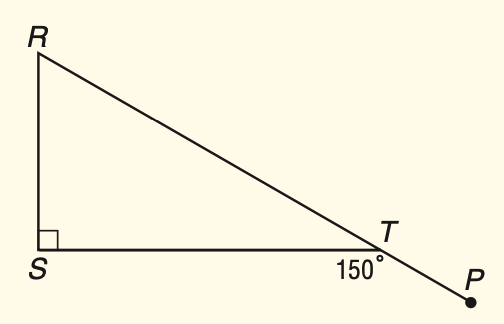Answer the mathemtical geometry problem and directly provide the correct option letter.
Question: \triangle R S T is a right triangle. Find m \angle R.
Choices: A: 30 B: 40 C: 50 D: 60 D 